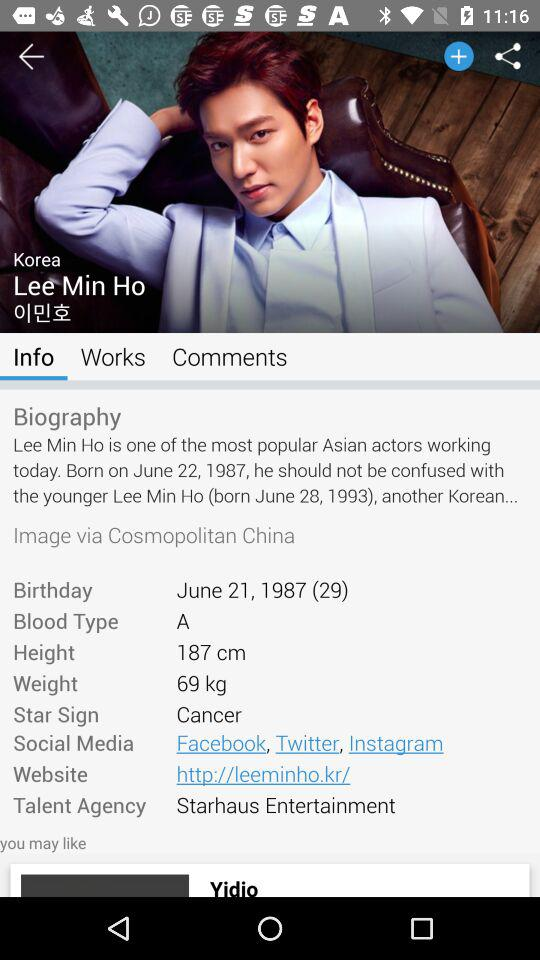How many social media platforms does Lee Min Ho have?
Answer the question using a single word or phrase. 3 